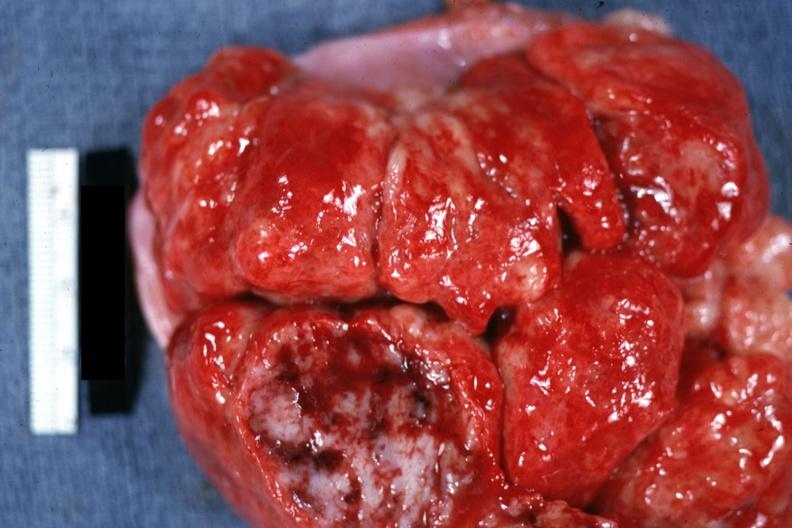what is present?
Answer the question using a single word or phrase. Lymph node 